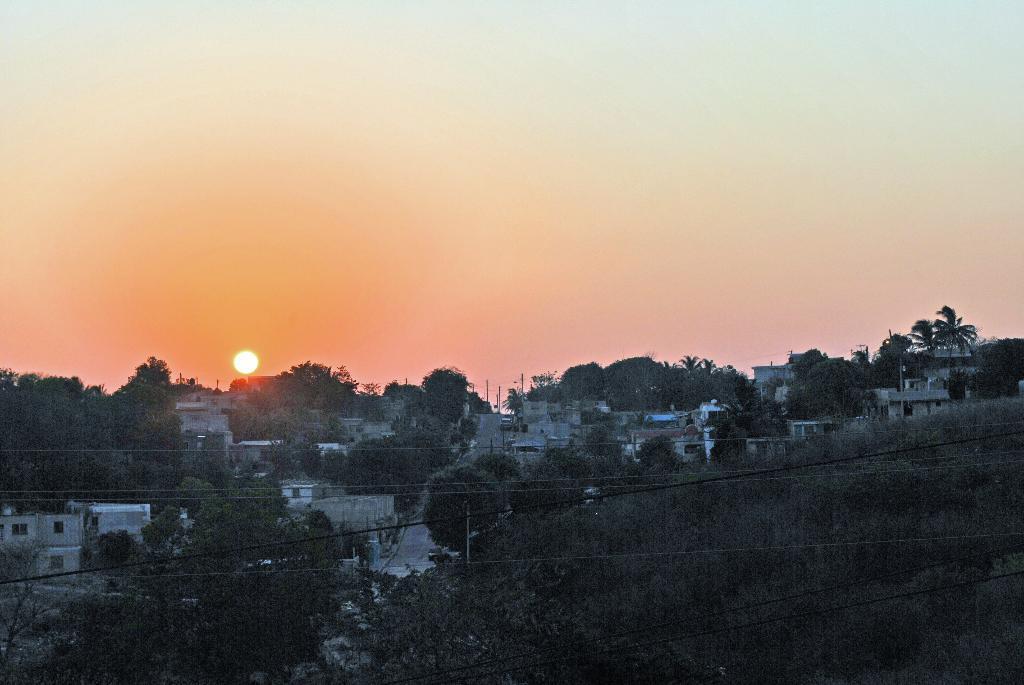Could you give a brief overview of what you see in this image? In this image we can see houses, trees, wires, also we can see the sun, and the sky. 